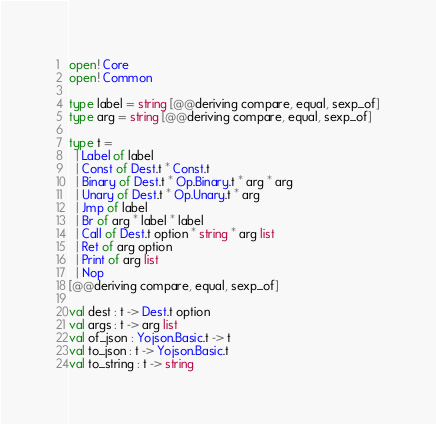Convert code to text. <code><loc_0><loc_0><loc_500><loc_500><_OCaml_>open! Core
open! Common

type label = string [@@deriving compare, equal, sexp_of]
type arg = string [@@deriving compare, equal, sexp_of]

type t =
  | Label of label
  | Const of Dest.t * Const.t
  | Binary of Dest.t * Op.Binary.t * arg * arg
  | Unary of Dest.t * Op.Unary.t * arg
  | Jmp of label
  | Br of arg * label * label
  | Call of Dest.t option * string * arg list
  | Ret of arg option
  | Print of arg list
  | Nop
[@@deriving compare, equal, sexp_of]

val dest : t -> Dest.t option
val args : t -> arg list
val of_json : Yojson.Basic.t -> t
val to_json : t -> Yojson.Basic.t
val to_string : t -> string
</code> 